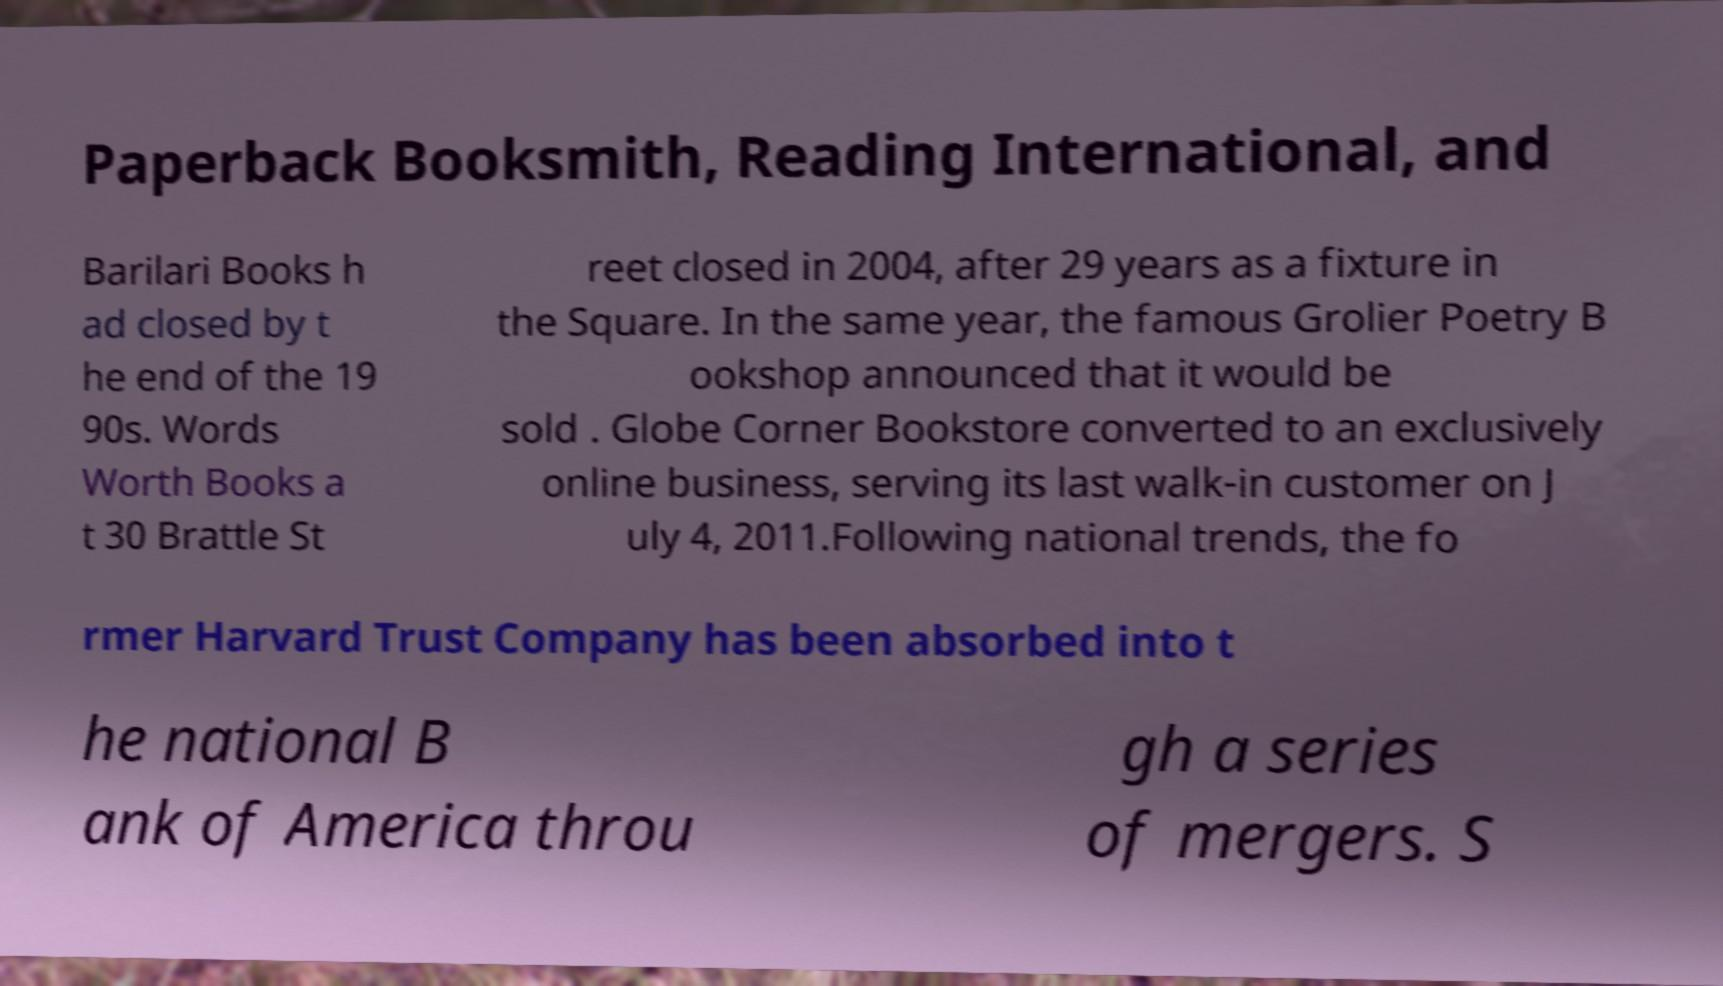I need the written content from this picture converted into text. Can you do that? Paperback Booksmith, Reading International, and Barilari Books h ad closed by t he end of the 19 90s. Words Worth Books a t 30 Brattle St reet closed in 2004, after 29 years as a fixture in the Square. In the same year, the famous Grolier Poetry B ookshop announced that it would be sold . Globe Corner Bookstore converted to an exclusively online business, serving its last walk-in customer on J uly 4, 2011.Following national trends, the fo rmer Harvard Trust Company has been absorbed into t he national B ank of America throu gh a series of mergers. S 